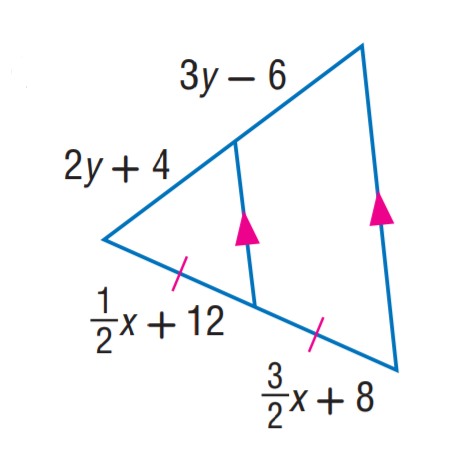Answer the mathemtical geometry problem and directly provide the correct option letter.
Question: Find y.
Choices: A: 8 B: 10 C: 12 D: 14 B 